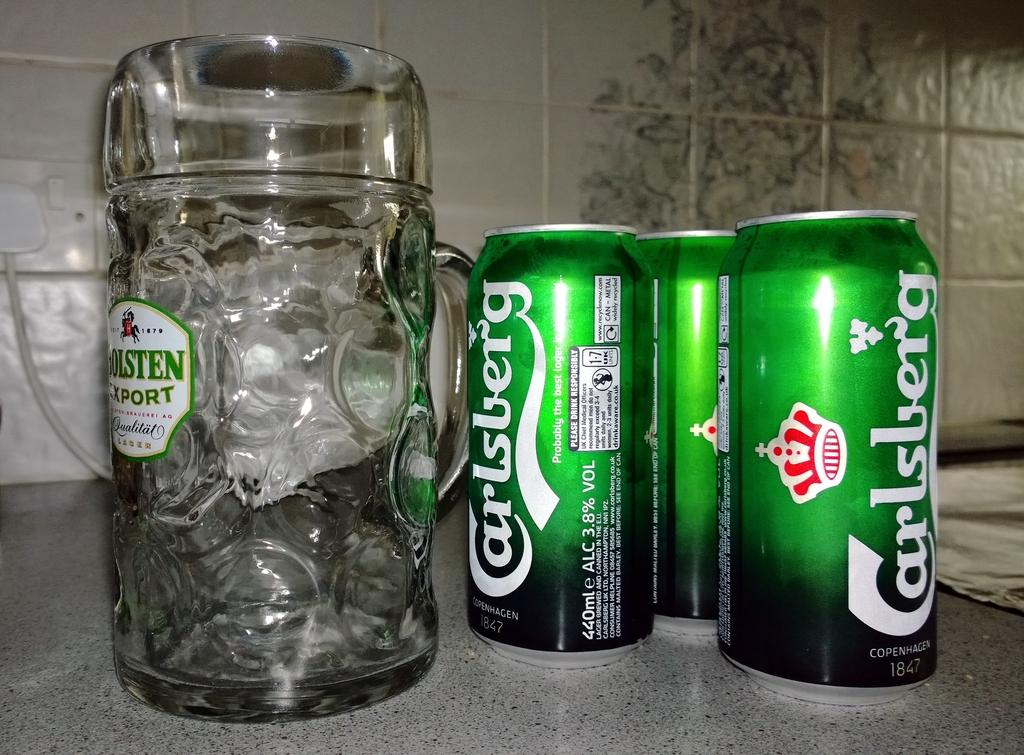<image>
Relay a brief, clear account of the picture shown. Green cans of Carlsberg beer are sitting by a large glass mug. 